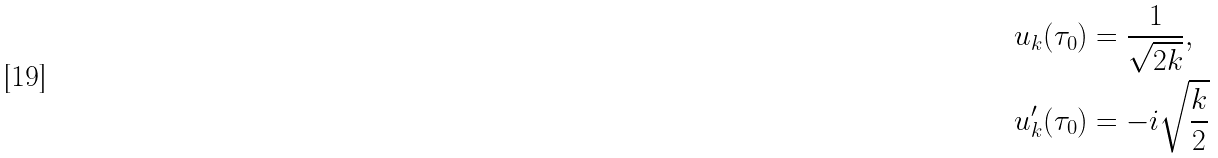Convert formula to latex. <formula><loc_0><loc_0><loc_500><loc_500>u _ { k } ( \tau _ { 0 } ) & = \frac { 1 } { \sqrt { 2 k } } , \\ u _ { k } ^ { \prime } ( \tau _ { 0 } ) & = - i \sqrt { \frac { k } { 2 } }</formula> 